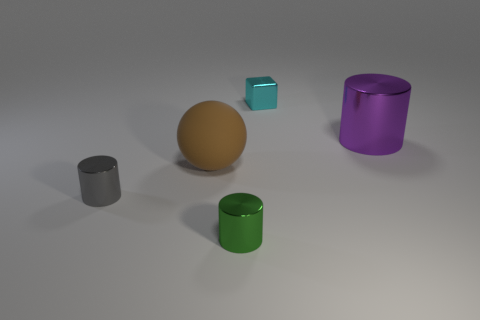Add 5 gray metal cylinders. How many objects exist? 10 Subtract all spheres. How many objects are left? 4 Subtract 0 yellow cubes. How many objects are left? 5 Subtract all big green balls. Subtract all tiny metallic cylinders. How many objects are left? 3 Add 4 cyan things. How many cyan things are left? 5 Add 2 rubber objects. How many rubber objects exist? 3 